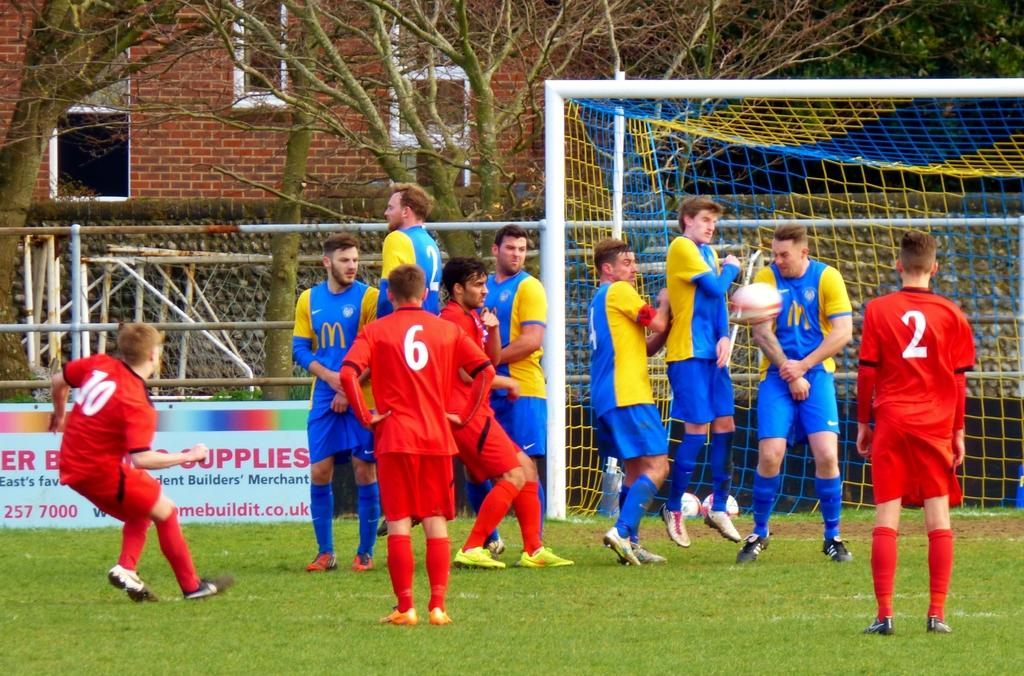What are the people in the image doing? The people in the image are playing. Where are they playing? They are playing on the grass. What can be seen in the background of the image? There is a wall, fencing, trees, and buildings in the image. What type of button can be seen on the fairies' clothing in the image? There are no fairies or buttons present in the image; it features people playing on the grass with a background of a wall, fencing, trees, and buildings. 